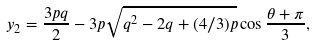<formula> <loc_0><loc_0><loc_500><loc_500>y _ { 2 } = \frac { 3 p q } { 2 } - 3 p \sqrt { q ^ { 2 } - 2 q + ( 4 / 3 ) p } \cos \frac { \theta + \pi } { 3 } ,</formula> 